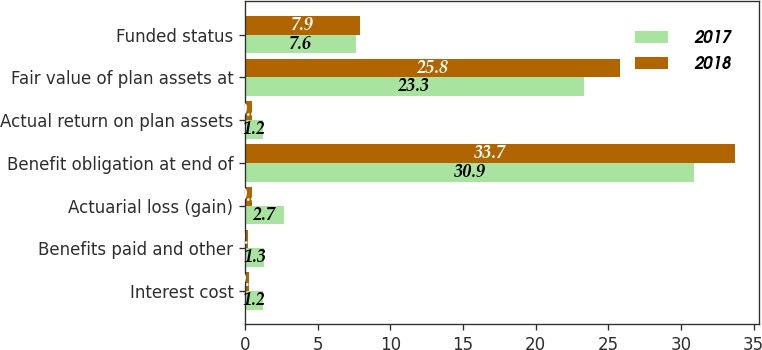Convert chart to OTSL. <chart><loc_0><loc_0><loc_500><loc_500><stacked_bar_chart><ecel><fcel>Interest cost<fcel>Benefits paid and other<fcel>Actuarial loss (gain)<fcel>Benefit obligation at end of<fcel>Actual return on plan assets<fcel>Fair value of plan assets at<fcel>Funded status<nl><fcel>2017<fcel>1.2<fcel>1.3<fcel>2.7<fcel>30.9<fcel>1.2<fcel>23.3<fcel>7.6<nl><fcel>2018<fcel>0.3<fcel>0.2<fcel>0.5<fcel>33.7<fcel>0.5<fcel>25.8<fcel>7.9<nl></chart> 